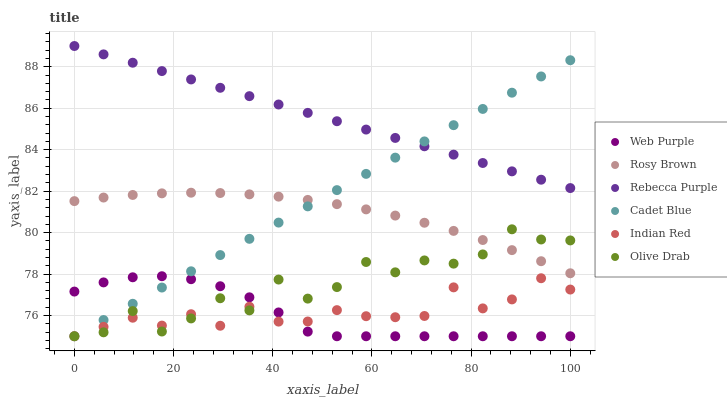Does Web Purple have the minimum area under the curve?
Answer yes or no. Yes. Does Rebecca Purple have the maximum area under the curve?
Answer yes or no. Yes. Does Rosy Brown have the minimum area under the curve?
Answer yes or no. No. Does Rosy Brown have the maximum area under the curve?
Answer yes or no. No. Is Cadet Blue the smoothest?
Answer yes or no. Yes. Is Olive Drab the roughest?
Answer yes or no. Yes. Is Rosy Brown the smoothest?
Answer yes or no. No. Is Rosy Brown the roughest?
Answer yes or no. No. Does Cadet Blue have the lowest value?
Answer yes or no. Yes. Does Rosy Brown have the lowest value?
Answer yes or no. No. Does Rebecca Purple have the highest value?
Answer yes or no. Yes. Does Rosy Brown have the highest value?
Answer yes or no. No. Is Indian Red less than Rosy Brown?
Answer yes or no. Yes. Is Rebecca Purple greater than Olive Drab?
Answer yes or no. Yes. Does Cadet Blue intersect Web Purple?
Answer yes or no. Yes. Is Cadet Blue less than Web Purple?
Answer yes or no. No. Is Cadet Blue greater than Web Purple?
Answer yes or no. No. Does Indian Red intersect Rosy Brown?
Answer yes or no. No. 